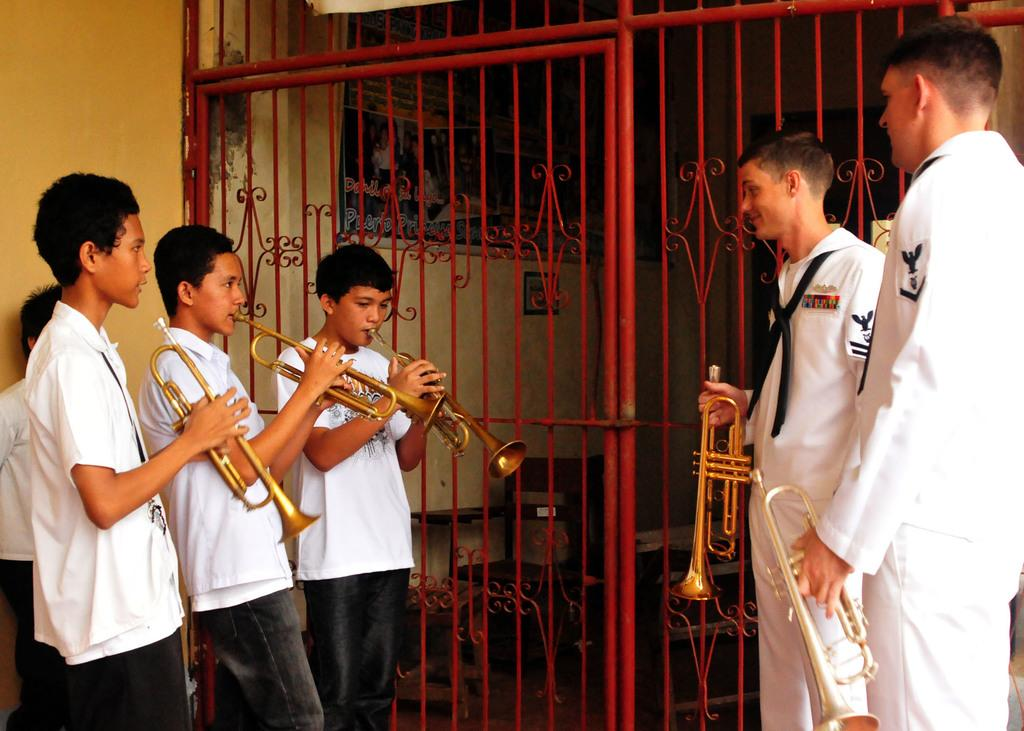How many boys are present in the image? There are six boys standing in the image. What are the boys wearing? The boys are wearing clothes. What are the boys holding in their hands? The boys are holding a musical instrument in their hands. What can be seen in the background of the image? There is a metal gate and a wall in the image. What type of ticket is required to enter the design on the wall in the image? There is no ticket or design on the wall in the image; it is a simple wall with a metal gate. 